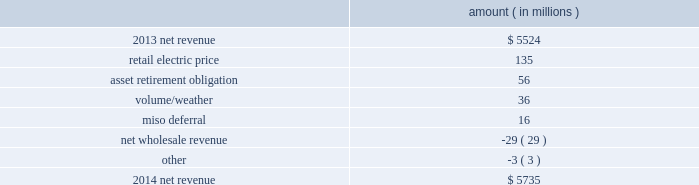Entergy corporation and subsidiaries management 2019s financial discussion and analysis net revenue utility following is an analysis of the change in net revenue comparing 2014 to 2013 .
Amount ( in millions ) .
The retail electric price variance is primarily due to : 2022 increases in the energy efficiency rider at entergy arkansas , as approved by the apsc , effective july 2013 and july 2014 .
Energy efficiency revenues are offset by costs included in other operation and maintenance expenses and have minimal effect on net income ; 2022 the effect of the apsc 2019s order in entergy arkansas 2019s 2013 rate case , including an annual base rate increase effective january 2014 offset by a miso rider to provide customers credits in rates for transmission revenue received through miso ; 2022 a formula rate plan increase at entergy mississippi , as approved by the mspc , effective september 2013 ; 2022 an increase in entergy mississippi 2019s storm damage rider , as approved by the mpsc , effective october 2013 .
The increase in the storm damage rider is offset by other operation and maintenance expenses and has no effect on net income ; 2022 an annual base rate increase at entergy texas , effective april 2014 , as a result of the puct 2019s order in the september 2013 rate case ; and 2022 a formula rate plan increase at entergy louisiana , as approved by the lpsc , effective december 2014 .
See note 2 to the financial statements for a discussion of rate proceedings .
The asset retirement obligation affects net revenue because entergy records a regulatory debit or credit for the difference between asset retirement obligation-related expenses and trust earnings plus asset retirement obligation- related costs collected in revenue .
The variance is primarily caused by increases in regulatory credits because of decreases in decommissioning trust earnings and increases in depreciation and accretion expenses and increases in regulatory credits to realign the asset retirement obligation regulatory assets with regulatory treatment .
The volume/weather variance is primarily due to an increase of 3129 gwh , or 3% ( 3 % ) , in billed electricity usage primarily due to an increase in sales to industrial customers and the effect of more favorable weather on residential sales .
The increase in industrial sales was primarily due to expansions , recovery of a major refining customer from an unplanned outage in 2013 , and continued moderate growth in the manufacturing sector .
The miso deferral variance is primarily due to the deferral in 2014 of the non-fuel miso-related charges , as approved by the lpsc and the mpsc , partially offset by the deferral in april 2013 , as approved by the apsc , of costs incurred from march 2010 through december 2012 related to the transition and implementation of joining the miso .
What is the percent change in net revenue from 2013 to 2014? 
Computations: ((5735 - 5524) / 5524)
Answer: 0.0382. 